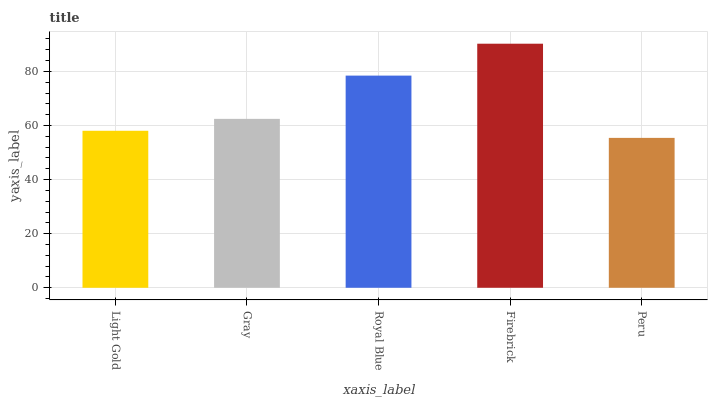Is Peru the minimum?
Answer yes or no. Yes. Is Firebrick the maximum?
Answer yes or no. Yes. Is Gray the minimum?
Answer yes or no. No. Is Gray the maximum?
Answer yes or no. No. Is Gray greater than Light Gold?
Answer yes or no. Yes. Is Light Gold less than Gray?
Answer yes or no. Yes. Is Light Gold greater than Gray?
Answer yes or no. No. Is Gray less than Light Gold?
Answer yes or no. No. Is Gray the high median?
Answer yes or no. Yes. Is Gray the low median?
Answer yes or no. Yes. Is Peru the high median?
Answer yes or no. No. Is Peru the low median?
Answer yes or no. No. 